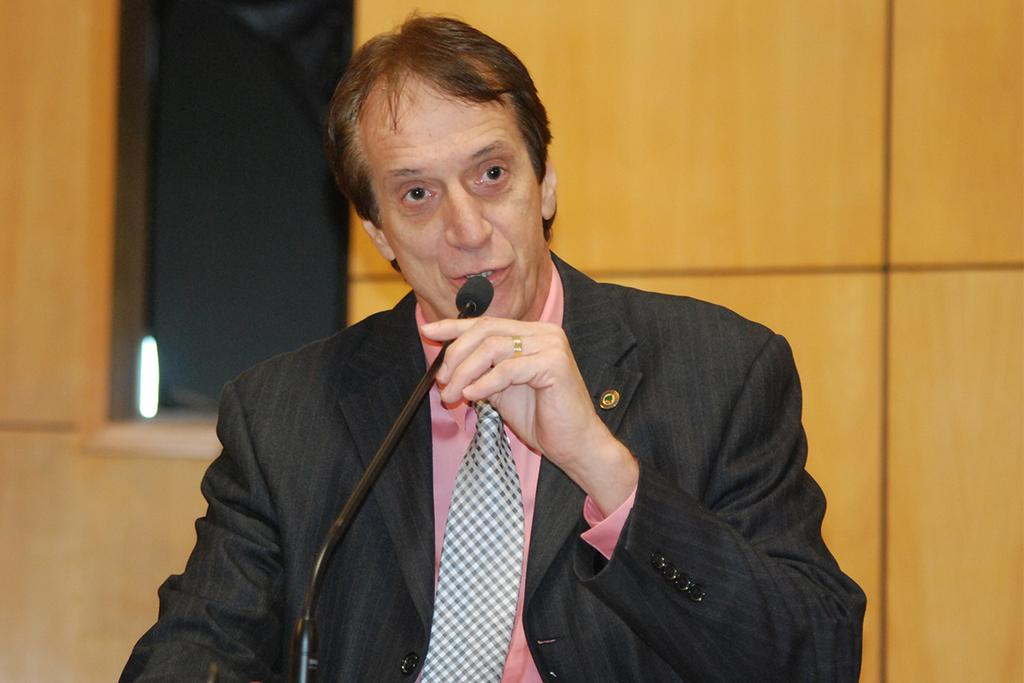Who is present in the image? There is a man in the image. What is the man holding in the image? The man is holding a microphone. What can be seen in the background of the image? There is a wall in the background of the image. What type of fiction is the man writing in the image? There is no indication in the image that the man is writing fiction or any other type of content. 